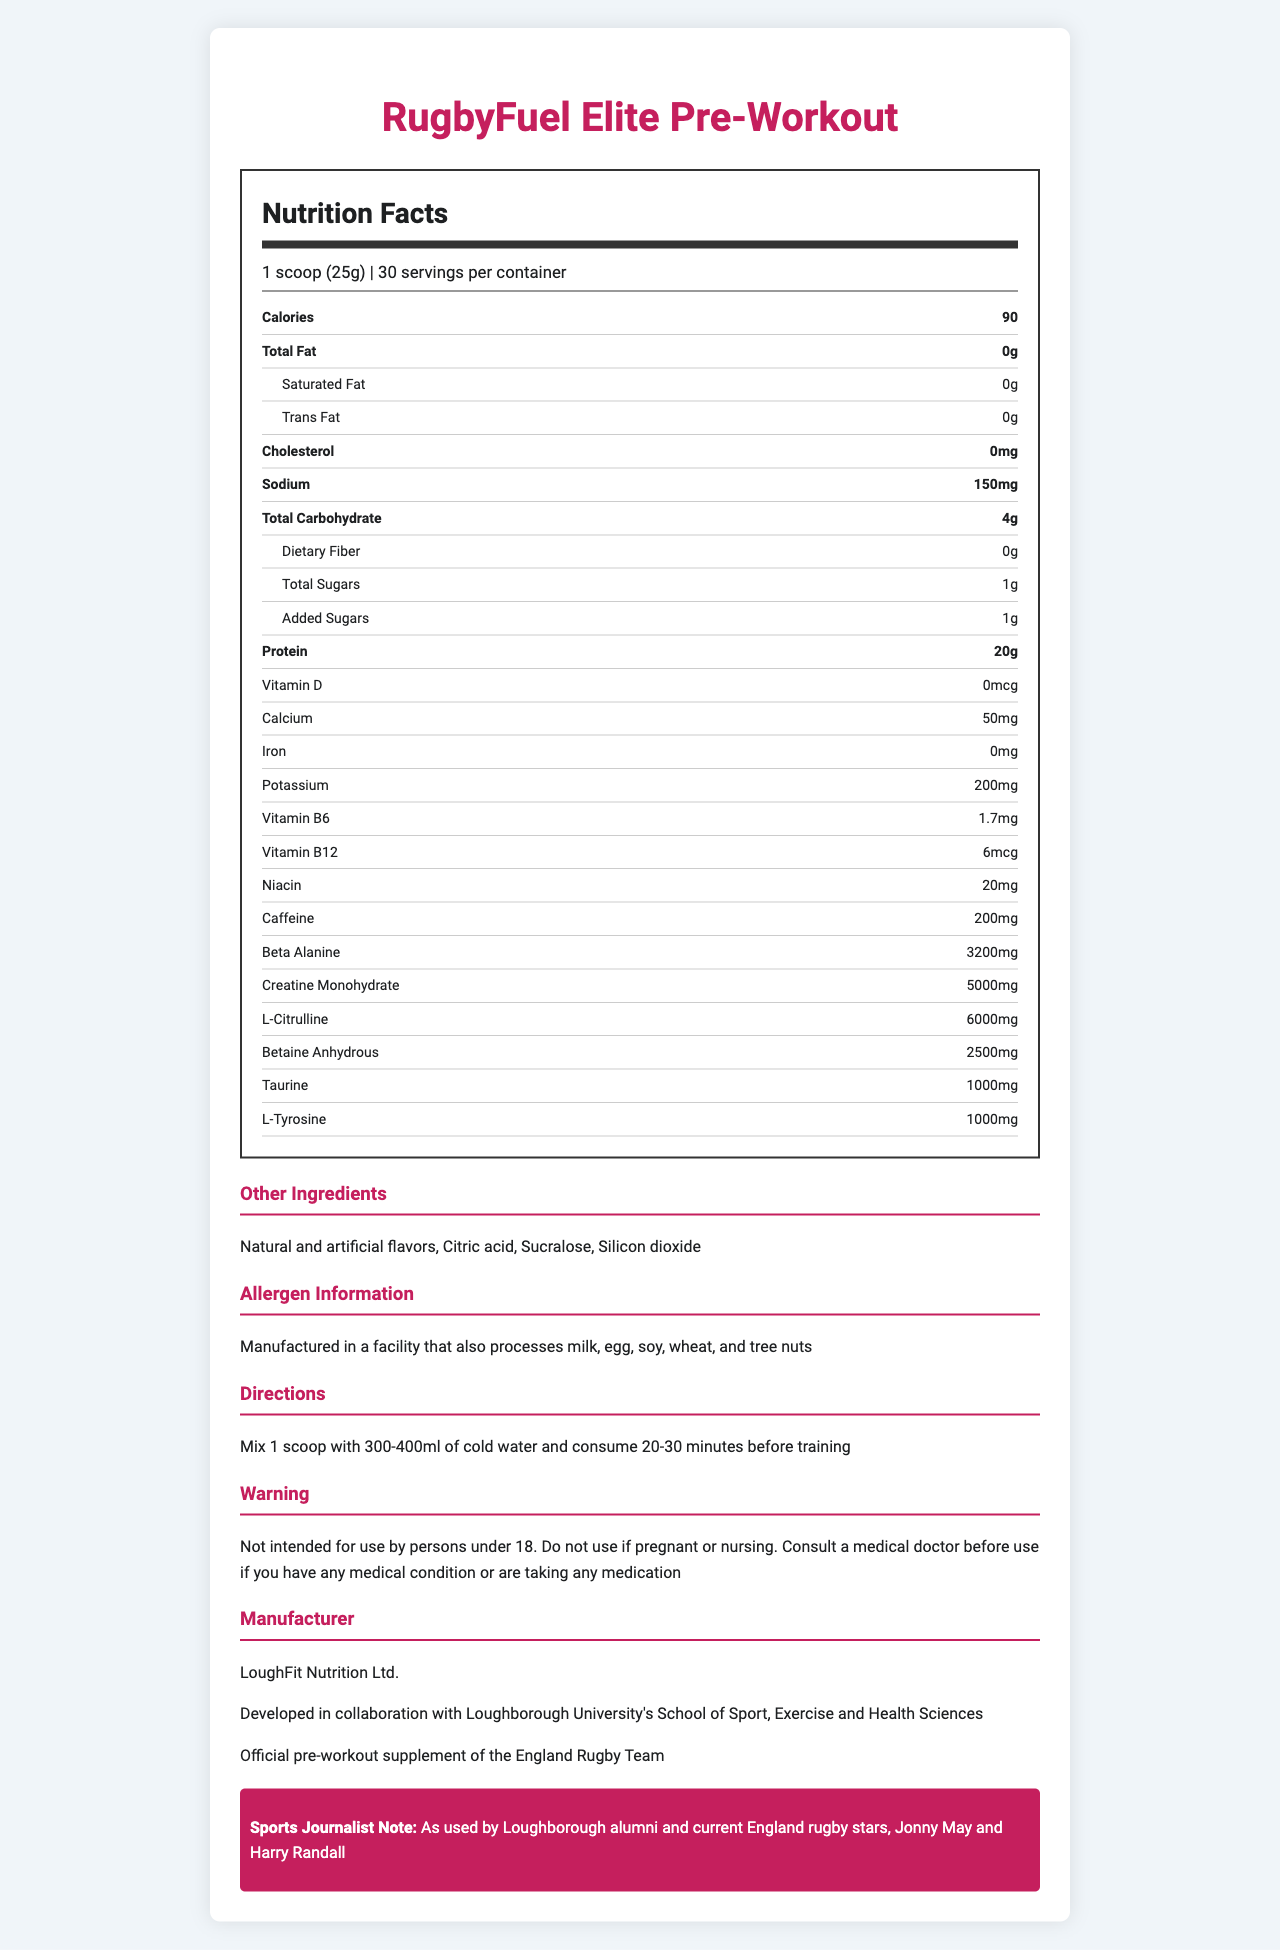what is the product name? The product name is prominently displayed at the top of the document.
Answer: RugbyFuel Elite Pre-Workout how many calories are in one serving? The calories per serving are listed directly under the serving size information.
Answer: 90 how much caffeine does one serving contain? The amount of caffeine per serving is listed in the ingredient section of the nutrition facts.
Answer: 200mg what allergens are processed in the facility where this product is manufactured? The allergen information is provided in a separate section towards the end of the document.
Answer: Milk, egg, soy, wheat, and tree nuts what is the amount of protein per serving? The amount of protein per serving is clearly listed in the nutrition facts section.
Answer: 20g how is this product connected to Loughborough University? This information is mentioned in the additional info section under the manufacturer details.
Answer: Developed in collaboration with Loughborough University's School of Sport, Exercise and Health Sciences what is the official pre-workout supplement of the England Rugby Team? A. ProteinPower Pre-Workout B. RugbyFuel Elite Pre-Workout C. EnduranceMax Pre-Workout The document states that RugbyFuel Elite Pre-Workout is the official pre-workout supplement of the England Rugby Team.
Answer: B how many servings are there per container? A. 20 B. 25 C. 30 D. 35 The document states that there are 30 servings per container.
Answer: C is this product intended for use by children under 18? The warning section specifies that the product is not intended for use by persons under 18.
Answer: No does one serving contain added sugars? The document states that there is 1g of added sugars per serving.
Answer: Yes summarize the main idea of this document The document provides comprehensive information on the nutritional content, ingredients, serving guidelines, and endorsements for the RugbyFuel Elite Pre-Workout supplement, highlighting its development collaboration with Loughborough University and endorsement by the England Rugby Team.
Answer: RugbyFuel Elite Pre-Workout is a specialized supplement designed for professional rugby players with a detailed nutrition facts label, serving and ingredient information, allergen warnings, and endorsement details. who are the Loughborough alumni mentioned in the document? The Sports Journalist Note section mentions that Jonny May and Harry Randall, both England rugby stars and Loughborough alumni, use this product.
Answer: Jonny May and Harry Randall how much sodium does one serving contain? The amount of sodium per serving is listed in the nutrition facts section.
Answer: 150mg how much beta alanine is in one serving? The amount of beta alanine per serving is listed among the ingredients in the nutrition facts section.
Answer: 3200mg what is the serving size? The serving size information is listed at the top of the nutrition facts label.
Answer: 1 scoop (25g) what are the directions for consuming this supplement? The directions are provided in a separate section towards the end of the document.
Answer: Mix 1 scoop with 300-400ml of cold water and consume 20-30 minutes before training how much creatine monohydrate is in one serving? The amount of creatine monohydrate per serving is listed among the ingredients in the nutrition facts section.
Answer: 5000mg is there any iron in this pre-workout supplement? The document indicates that there is no iron content listed in the included nutrients.
Answer: No how much vitamin B6 is in one serving? The amount of vitamin B6 per serving is listed in the nutrition facts section.
Answer: 1.7mg who manufactures this supplement? The manufacturer information is provided at the end of the document.
Answer: LoughFit Nutrition Ltd. how much l-citrulline is in one serving? The amount of l-citrulline per serving is listed among the ingredients.
Answer: 6000mg does this product contain silicon dioxide? Silicon dioxide is listed as one of the other ingredients.
Answer: Yes how long before training should this supplement be consumed? The directions state to consume the supplement 20-30 minutes before training.
Answer: 20-30 minutes is vitamin D included in this supplement? The document shows that Vitamin D is included but it mentions as "0mcg" in the nutritional label indicating a negligible amount.
Answer: Yes what flavors are used in this product? The flavors are listed in the other ingredients section.
Answer: Natural and artificial flavors where was this product developed? This collaboration is highlighted in the additional information section under manufacturer details.
Answer: In collaboration with Loughborough University's School of Sport, Exercise and Health Sciences 